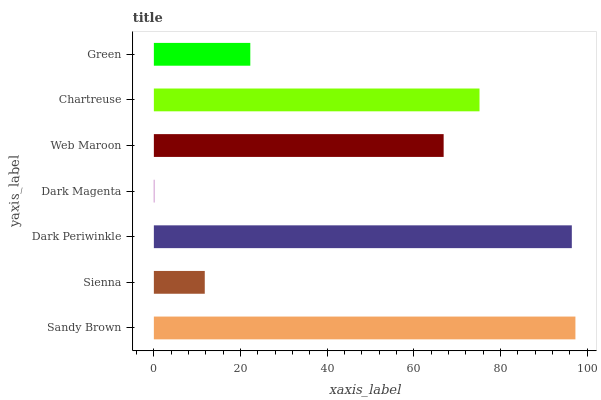Is Dark Magenta the minimum?
Answer yes or no. Yes. Is Sandy Brown the maximum?
Answer yes or no. Yes. Is Sienna the minimum?
Answer yes or no. No. Is Sienna the maximum?
Answer yes or no. No. Is Sandy Brown greater than Sienna?
Answer yes or no. Yes. Is Sienna less than Sandy Brown?
Answer yes or no. Yes. Is Sienna greater than Sandy Brown?
Answer yes or no. No. Is Sandy Brown less than Sienna?
Answer yes or no. No. Is Web Maroon the high median?
Answer yes or no. Yes. Is Web Maroon the low median?
Answer yes or no. Yes. Is Sienna the high median?
Answer yes or no. No. Is Dark Magenta the low median?
Answer yes or no. No. 